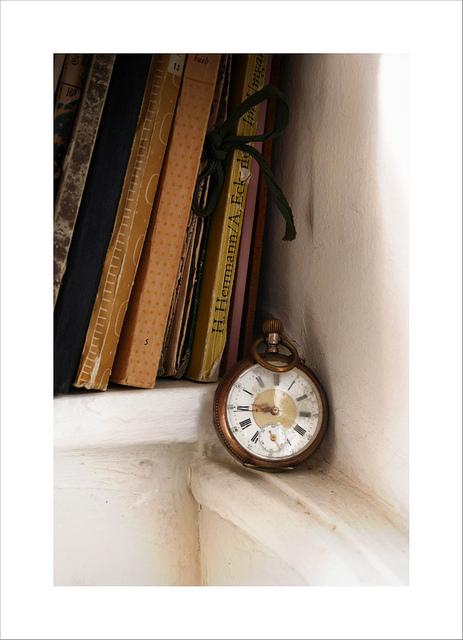What time is on the clock?
Answer briefly. 9:45. Are the walls painted?
Short answer required. Yes. What colors are the wall?
Be succinct. White. 